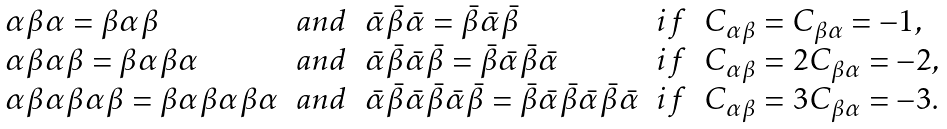Convert formula to latex. <formula><loc_0><loc_0><loc_500><loc_500>\begin{array} { l c l c l } \alpha \beta \alpha = \beta \alpha \beta & a n d & \bar { \alpha } \bar { \beta } \bar { \alpha } = \bar { \beta } \bar { \alpha } \bar { \beta } & i f & C _ { \alpha \beta } = C _ { \beta \alpha } = - 1 , \\ \alpha \beta \alpha \beta = \beta \alpha \beta \alpha & a n d & \bar { \alpha } \bar { \beta } \bar { \alpha } \bar { \beta } = \bar { \beta } \bar { \alpha } \bar { \beta } \bar { \alpha } & i f & C _ { \alpha \beta } = 2 C _ { \beta \alpha } = - 2 , \\ \alpha \beta \alpha \beta \alpha \beta = \beta \alpha \beta \alpha \beta \alpha & a n d & \bar { \alpha } \bar { \beta } \bar { \alpha } \bar { \beta } \bar { \alpha } \bar { \beta } = \bar { \beta } \bar { \alpha } \bar { \beta } \bar { \alpha } \bar { \beta } \bar { \alpha } & i f & C _ { \alpha \beta } = 3 C _ { \beta \alpha } = - 3 . \end{array}</formula> 